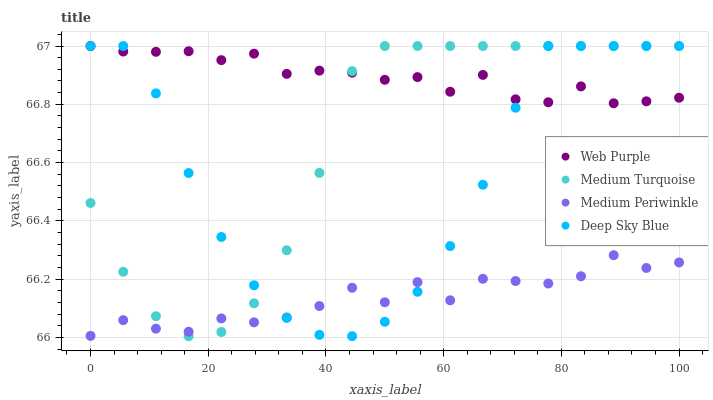Does Medium Periwinkle have the minimum area under the curve?
Answer yes or no. Yes. Does Web Purple have the maximum area under the curve?
Answer yes or no. Yes. Does Deep Sky Blue have the minimum area under the curve?
Answer yes or no. No. Does Deep Sky Blue have the maximum area under the curve?
Answer yes or no. No. Is Medium Turquoise the smoothest?
Answer yes or no. Yes. Is Medium Periwinkle the roughest?
Answer yes or no. Yes. Is Deep Sky Blue the smoothest?
Answer yes or no. No. Is Deep Sky Blue the roughest?
Answer yes or no. No. Does Medium Turquoise have the lowest value?
Answer yes or no. Yes. Does Medium Periwinkle have the lowest value?
Answer yes or no. No. Does Medium Turquoise have the highest value?
Answer yes or no. Yes. Does Medium Periwinkle have the highest value?
Answer yes or no. No. Is Medium Periwinkle less than Web Purple?
Answer yes or no. Yes. Is Web Purple greater than Medium Periwinkle?
Answer yes or no. Yes. Does Web Purple intersect Deep Sky Blue?
Answer yes or no. Yes. Is Web Purple less than Deep Sky Blue?
Answer yes or no. No. Is Web Purple greater than Deep Sky Blue?
Answer yes or no. No. Does Medium Periwinkle intersect Web Purple?
Answer yes or no. No. 